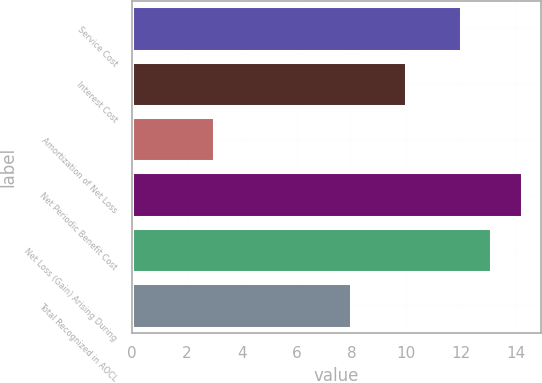<chart> <loc_0><loc_0><loc_500><loc_500><bar_chart><fcel>Service Cost<fcel>Interest Cost<fcel>Amortization of Net Loss<fcel>Net Periodic Benefit Cost<fcel>Net Loss (Gain) Arising During<fcel>Total Recognized in AOCL<nl><fcel>12<fcel>10<fcel>3<fcel>14.2<fcel>13.1<fcel>8<nl></chart> 